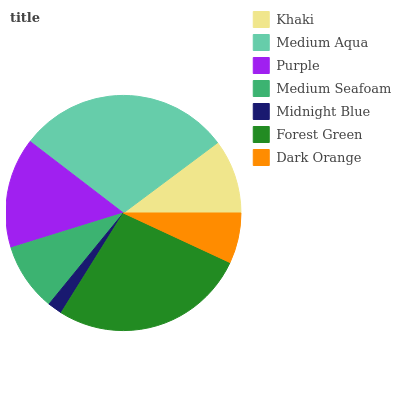Is Midnight Blue the minimum?
Answer yes or no. Yes. Is Medium Aqua the maximum?
Answer yes or no. Yes. Is Purple the minimum?
Answer yes or no. No. Is Purple the maximum?
Answer yes or no. No. Is Medium Aqua greater than Purple?
Answer yes or no. Yes. Is Purple less than Medium Aqua?
Answer yes or no. Yes. Is Purple greater than Medium Aqua?
Answer yes or no. No. Is Medium Aqua less than Purple?
Answer yes or no. No. Is Khaki the high median?
Answer yes or no. Yes. Is Khaki the low median?
Answer yes or no. Yes. Is Dark Orange the high median?
Answer yes or no. No. Is Midnight Blue the low median?
Answer yes or no. No. 